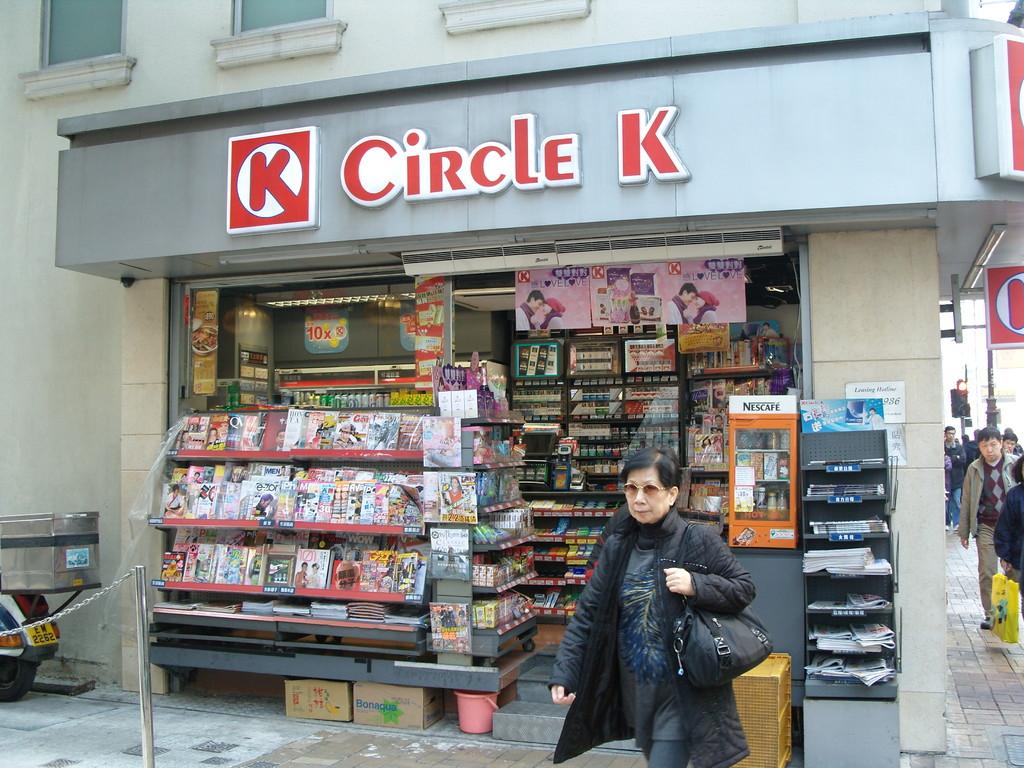What letter is inside the red circle?
Your response must be concise. K. 